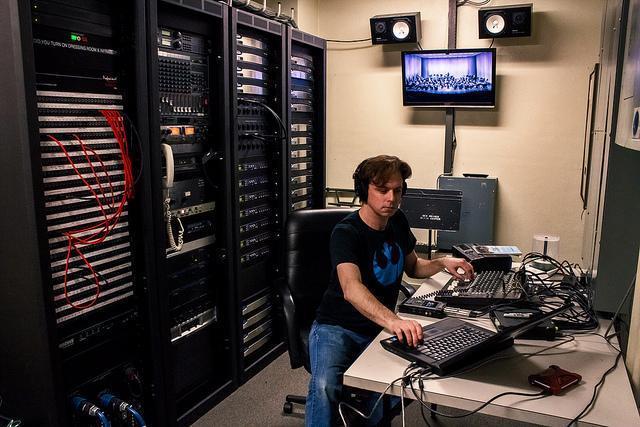How many zebras are seen in the mirror?
Give a very brief answer. 0. 